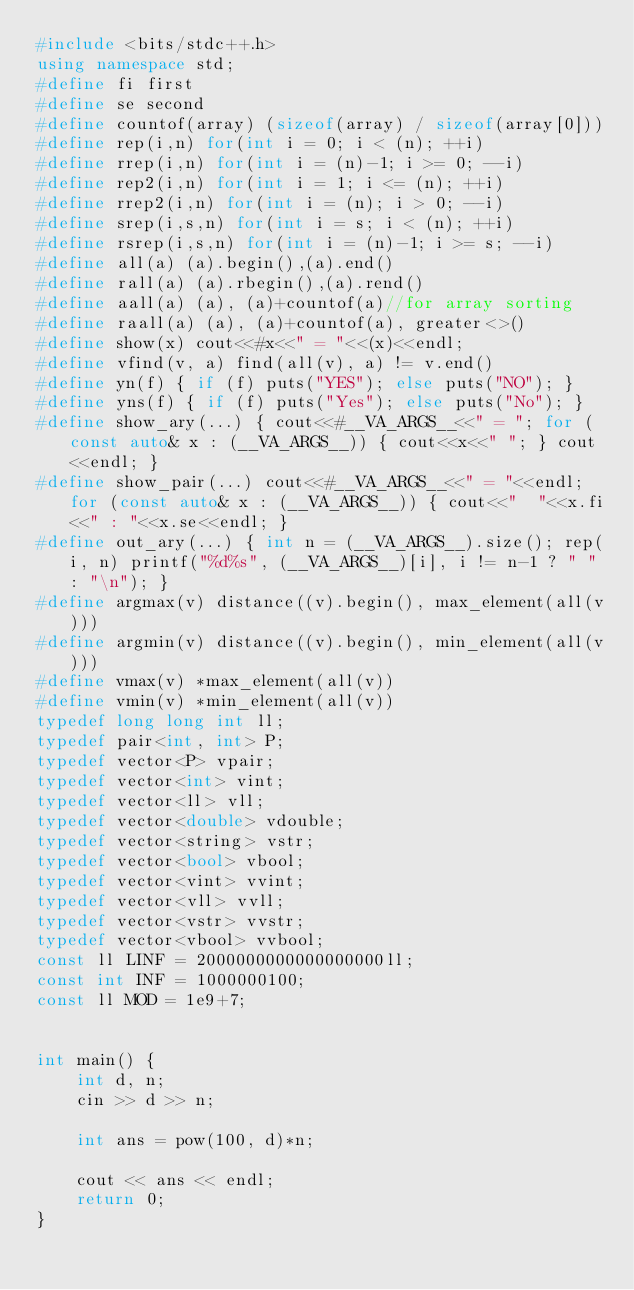<code> <loc_0><loc_0><loc_500><loc_500><_C++_>#include <bits/stdc++.h>
using namespace std;
#define fi first
#define se second
#define countof(array) (sizeof(array) / sizeof(array[0]))
#define rep(i,n) for(int i = 0; i < (n); ++i)
#define rrep(i,n) for(int i = (n)-1; i >= 0; --i)
#define rep2(i,n) for(int i = 1; i <= (n); ++i)
#define rrep2(i,n) for(int i = (n); i > 0; --i)
#define srep(i,s,n) for(int i = s; i < (n); ++i)
#define rsrep(i,s,n) for(int i = (n)-1; i >= s; --i)
#define all(a) (a).begin(),(a).end()
#define rall(a) (a).rbegin(),(a).rend()
#define aall(a) (a), (a)+countof(a)//for array sorting
#define raall(a) (a), (a)+countof(a), greater<>()
#define show(x) cout<<#x<<" = "<<(x)<<endl;
#define vfind(v, a) find(all(v), a) != v.end()
#define yn(f) { if (f) puts("YES"); else puts("NO"); }
#define yns(f) { if (f) puts("Yes"); else puts("No"); }
#define show_ary(...) { cout<<#__VA_ARGS__<<" = "; for (const auto& x : (__VA_ARGS__)) { cout<<x<<" "; } cout<<endl; }
#define show_pair(...) cout<<#__VA_ARGS__<<" = "<<endl; for (const auto& x : (__VA_ARGS__)) { cout<<"  "<<x.fi<<" : "<<x.se<<endl; }
#define out_ary(...) { int n = (__VA_ARGS__).size(); rep(i, n) printf("%d%s", (__VA_ARGS__)[i], i != n-1 ? " " : "\n"); }
#define argmax(v) distance((v).begin(), max_element(all(v)))
#define argmin(v) distance((v).begin(), min_element(all(v)))
#define vmax(v) *max_element(all(v))
#define vmin(v) *min_element(all(v))
typedef long long int ll;
typedef pair<int, int> P;
typedef vector<P> vpair;
typedef vector<int> vint;
typedef vector<ll> vll;
typedef vector<double> vdouble;
typedef vector<string> vstr;
typedef vector<bool> vbool;
typedef vector<vint> vvint;
typedef vector<vll> vvll;
typedef vector<vstr> vvstr;
typedef vector<vbool> vvbool;
const ll LINF = 2000000000000000000ll;
const int INF = 1000000100;
const ll MOD = 1e9+7;


int main() {
    int d, n;
    cin >> d >> n;

    int ans = pow(100, d)*n;

    cout << ans << endl;
    return 0;
}</code> 